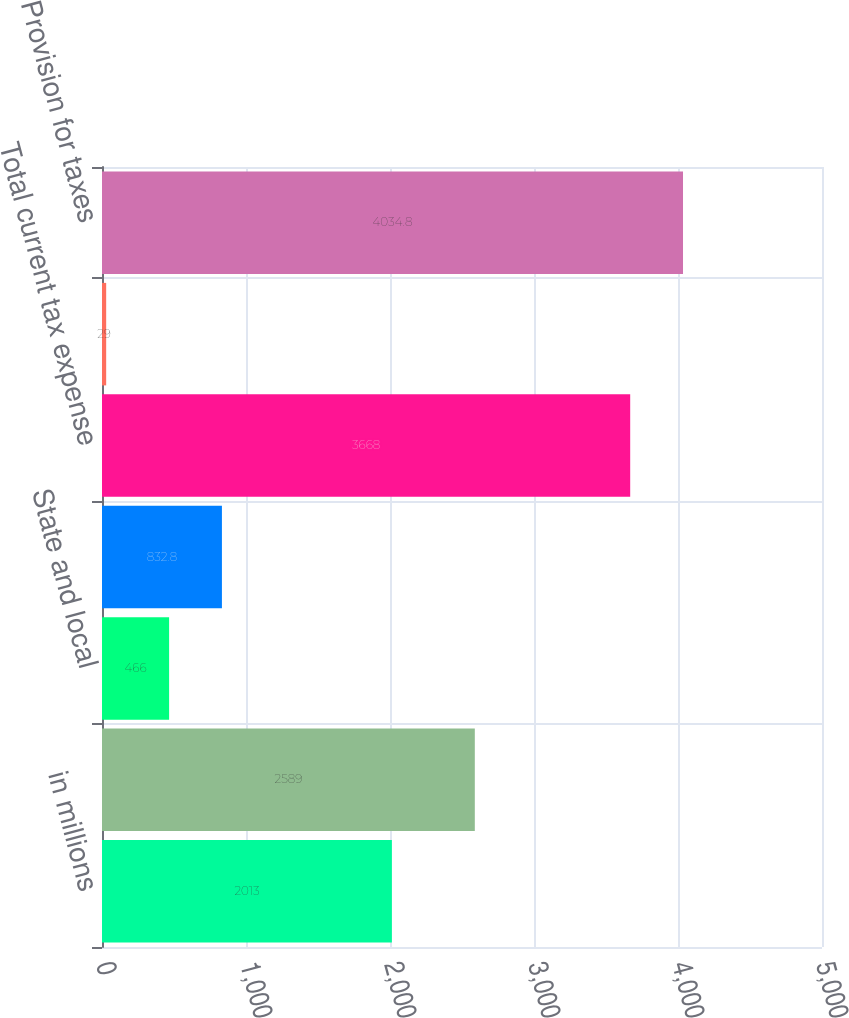Convert chart to OTSL. <chart><loc_0><loc_0><loc_500><loc_500><bar_chart><fcel>in millions<fcel>US federal<fcel>State and local<fcel>Non-US<fcel>Total current tax expense<fcel>Total deferred tax<fcel>Provision for taxes<nl><fcel>2013<fcel>2589<fcel>466<fcel>832.8<fcel>3668<fcel>29<fcel>4034.8<nl></chart> 